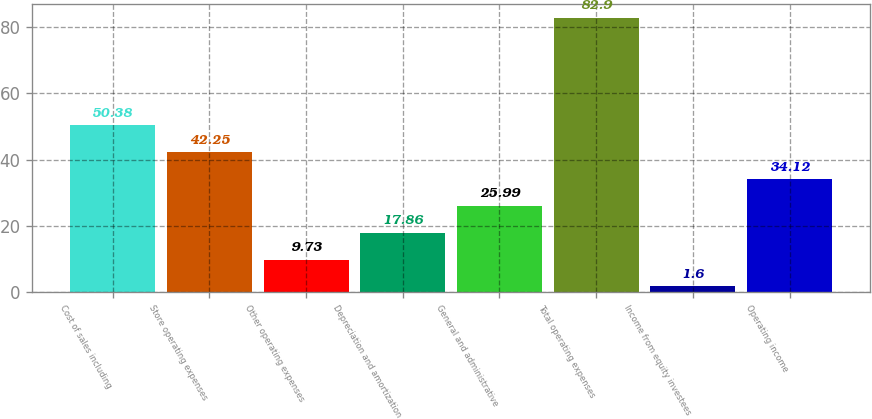<chart> <loc_0><loc_0><loc_500><loc_500><bar_chart><fcel>Cost of sales including<fcel>Store operating expenses<fcel>Other operating expenses<fcel>Depreciation and amortization<fcel>General and administrative<fcel>Total operating expenses<fcel>Income from equity investees<fcel>Operating income<nl><fcel>50.38<fcel>42.25<fcel>9.73<fcel>17.86<fcel>25.99<fcel>82.9<fcel>1.6<fcel>34.12<nl></chart> 